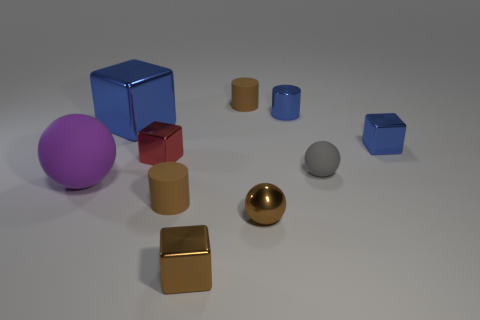Subtract all brown cylinders. How many were subtracted if there are1brown cylinders left? 1 Subtract all spheres. How many objects are left? 7 Add 6 big metal blocks. How many big metal blocks are left? 7 Add 7 small brown metallic cubes. How many small brown metallic cubes exist? 8 Subtract 0 cyan blocks. How many objects are left? 10 Subtract all blue metal blocks. Subtract all cubes. How many objects are left? 4 